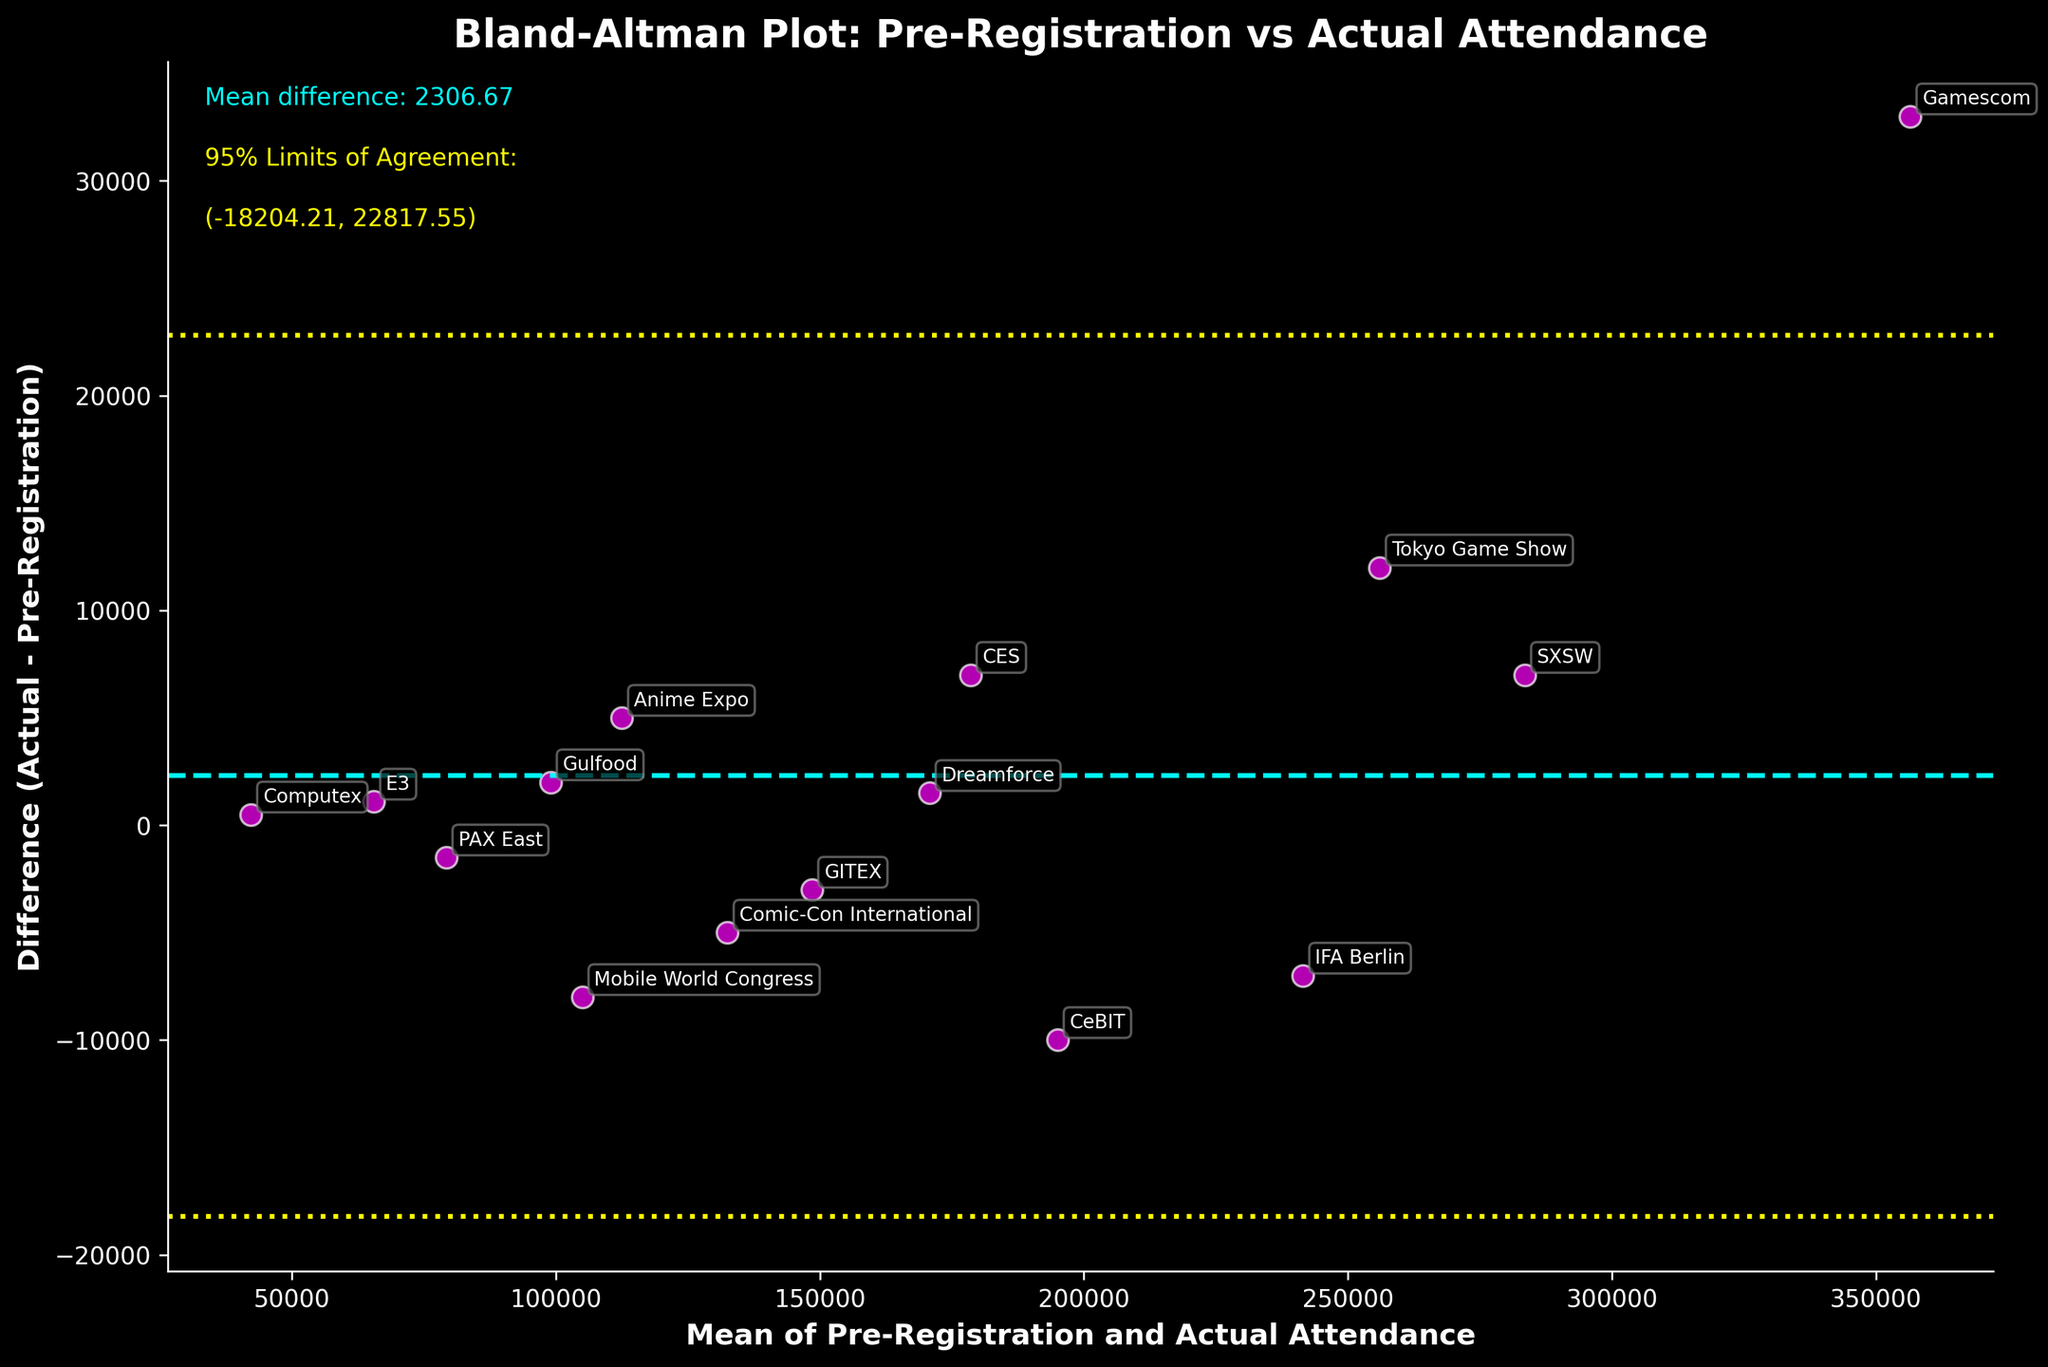How many events are represented in the plot? Count the number of data points (scatters) in the plot, each representing an event. There are 15 events based on the provided data.
Answer: 15 What is the title of the plot? The title is written at the top center of the plot.
Answer: Bland-Altman Plot: Pre-Registration vs Actual Attendance What do the yellow dotted lines represent in the plot? The yellow dotted lines are labeled as the "95% Limits of Agreement" and indicate the range within which most differences between actual attendance and pre-registration fall.
Answer: 95% Limits of Agreement Which event has the largest positive difference between actual attendance and pre-registration? Find the data point (scatter) highest above the mean difference line. Based on the annotation, Gamescom has the largest positive difference.
Answer: Gamescom What is the mean difference between actual attendance and pre-registration across all events? Refer to the cyan dashed line labeled "Mean difference" on the plot.
Answer: ~1,933.33 What are the 95% Limits of Agreement for the differences between actual attendance and pre-registration? Check the yellow text labeled "95% Limits of Agreement" on the plot.
Answer: (-30,333.95, 34,200.62) Did the actual attendance exceed pre-registration for the CES event? Identify the data point labeled "CES" and see if it is above the zero difference line.
Answer: Yes Which event has the smallest absolute difference between actual attendance and pre-registration? Find the data point closest to the zero difference line in the vertical direction. Based on the annotations, Gulfood has the smallest absolute difference.
Answer: Gulfood Which event had fewer actual attendees than pre-registered? Identify data points below the zero difference line (negative differences) and refer to their annotations. Events like Mobile World Congress, Comic-Con International, and GITEX fall into this category.
Answer: Mobile World Congress, Comic-Con International, GITEX What does the cyan dashed line in the plot represent? The cyan dashed line indicates the mean difference between actual attendance and pre-registration.
Answer: Mean Difference 